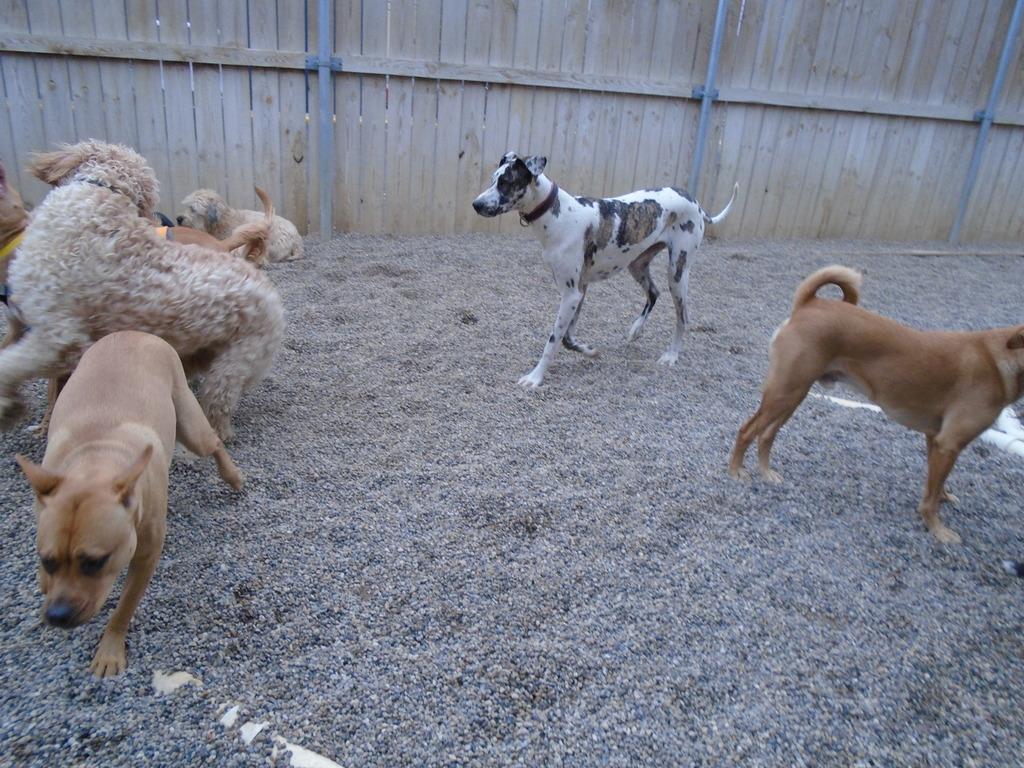Could you give a brief overview of what you see in this image? In this picture, we can see a few dogs on the ground and we can see a wooden wall with some poles. 